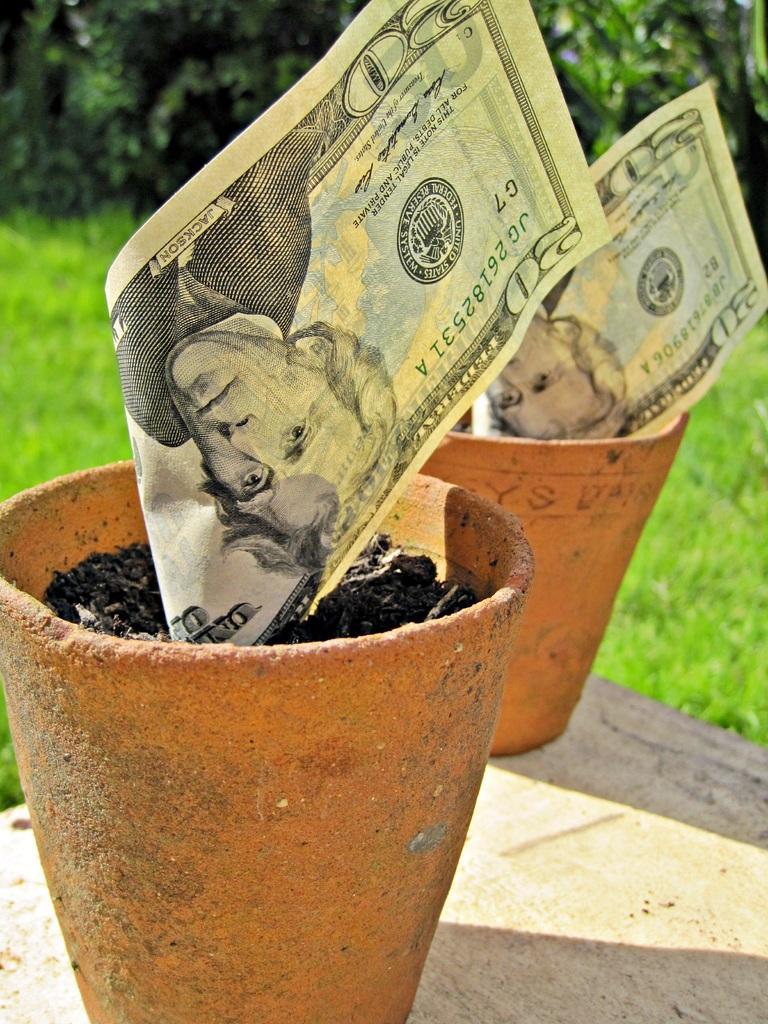Describe this image in one or two sentences. In this image, we can see currency notes on flower pots. In the background, image is blurred. 